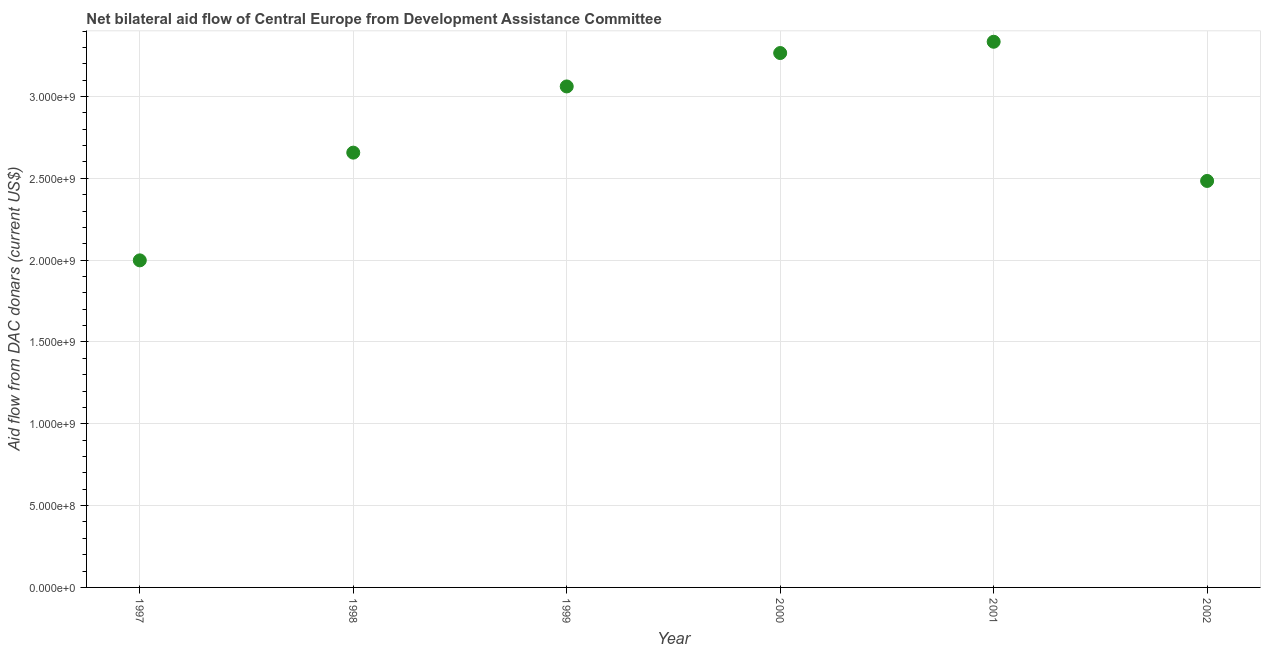What is the net bilateral aid flows from dac donors in 2001?
Offer a very short reply. 3.33e+09. Across all years, what is the maximum net bilateral aid flows from dac donors?
Make the answer very short. 3.33e+09. Across all years, what is the minimum net bilateral aid flows from dac donors?
Provide a short and direct response. 2.00e+09. In which year was the net bilateral aid flows from dac donors maximum?
Your answer should be compact. 2001. What is the sum of the net bilateral aid flows from dac donors?
Offer a terse response. 1.68e+1. What is the difference between the net bilateral aid flows from dac donors in 1997 and 2000?
Provide a succinct answer. -1.27e+09. What is the average net bilateral aid flows from dac donors per year?
Keep it short and to the point. 2.80e+09. What is the median net bilateral aid flows from dac donors?
Your answer should be very brief. 2.86e+09. What is the ratio of the net bilateral aid flows from dac donors in 1997 to that in 1998?
Offer a very short reply. 0.75. Is the net bilateral aid flows from dac donors in 1998 less than that in 2000?
Offer a terse response. Yes. Is the difference between the net bilateral aid flows from dac donors in 1997 and 2002 greater than the difference between any two years?
Give a very brief answer. No. What is the difference between the highest and the second highest net bilateral aid flows from dac donors?
Keep it short and to the point. 6.89e+07. Is the sum of the net bilateral aid flows from dac donors in 1998 and 2001 greater than the maximum net bilateral aid flows from dac donors across all years?
Provide a short and direct response. Yes. What is the difference between the highest and the lowest net bilateral aid flows from dac donors?
Your answer should be very brief. 1.34e+09. Does the net bilateral aid flows from dac donors monotonically increase over the years?
Provide a short and direct response. No. How many dotlines are there?
Keep it short and to the point. 1. Are the values on the major ticks of Y-axis written in scientific E-notation?
Your answer should be compact. Yes. What is the title of the graph?
Ensure brevity in your answer.  Net bilateral aid flow of Central Europe from Development Assistance Committee. What is the label or title of the X-axis?
Provide a short and direct response. Year. What is the label or title of the Y-axis?
Provide a short and direct response. Aid flow from DAC donars (current US$). What is the Aid flow from DAC donars (current US$) in 1997?
Give a very brief answer. 2.00e+09. What is the Aid flow from DAC donars (current US$) in 1998?
Make the answer very short. 2.66e+09. What is the Aid flow from DAC donars (current US$) in 1999?
Give a very brief answer. 3.06e+09. What is the Aid flow from DAC donars (current US$) in 2000?
Provide a short and direct response. 3.27e+09. What is the Aid flow from DAC donars (current US$) in 2001?
Offer a terse response. 3.33e+09. What is the Aid flow from DAC donars (current US$) in 2002?
Your answer should be very brief. 2.48e+09. What is the difference between the Aid flow from DAC donars (current US$) in 1997 and 1998?
Keep it short and to the point. -6.58e+08. What is the difference between the Aid flow from DAC donars (current US$) in 1997 and 1999?
Your answer should be compact. -1.06e+09. What is the difference between the Aid flow from DAC donars (current US$) in 1997 and 2000?
Provide a succinct answer. -1.27e+09. What is the difference between the Aid flow from DAC donars (current US$) in 1997 and 2001?
Your response must be concise. -1.34e+09. What is the difference between the Aid flow from DAC donars (current US$) in 1997 and 2002?
Make the answer very short. -4.85e+08. What is the difference between the Aid flow from DAC donars (current US$) in 1998 and 1999?
Your answer should be compact. -4.04e+08. What is the difference between the Aid flow from DAC donars (current US$) in 1998 and 2000?
Make the answer very short. -6.09e+08. What is the difference between the Aid flow from DAC donars (current US$) in 1998 and 2001?
Give a very brief answer. -6.78e+08. What is the difference between the Aid flow from DAC donars (current US$) in 1998 and 2002?
Provide a short and direct response. 1.73e+08. What is the difference between the Aid flow from DAC donars (current US$) in 1999 and 2000?
Give a very brief answer. -2.04e+08. What is the difference between the Aid flow from DAC donars (current US$) in 1999 and 2001?
Your response must be concise. -2.73e+08. What is the difference between the Aid flow from DAC donars (current US$) in 1999 and 2002?
Your answer should be very brief. 5.77e+08. What is the difference between the Aid flow from DAC donars (current US$) in 2000 and 2001?
Offer a very short reply. -6.89e+07. What is the difference between the Aid flow from DAC donars (current US$) in 2000 and 2002?
Provide a short and direct response. 7.82e+08. What is the difference between the Aid flow from DAC donars (current US$) in 2001 and 2002?
Provide a short and direct response. 8.51e+08. What is the ratio of the Aid flow from DAC donars (current US$) in 1997 to that in 1998?
Provide a succinct answer. 0.75. What is the ratio of the Aid flow from DAC donars (current US$) in 1997 to that in 1999?
Your answer should be compact. 0.65. What is the ratio of the Aid flow from DAC donars (current US$) in 1997 to that in 2000?
Your response must be concise. 0.61. What is the ratio of the Aid flow from DAC donars (current US$) in 1997 to that in 2001?
Make the answer very short. 0.6. What is the ratio of the Aid flow from DAC donars (current US$) in 1997 to that in 2002?
Your answer should be very brief. 0.81. What is the ratio of the Aid flow from DAC donars (current US$) in 1998 to that in 1999?
Offer a very short reply. 0.87. What is the ratio of the Aid flow from DAC donars (current US$) in 1998 to that in 2000?
Provide a short and direct response. 0.81. What is the ratio of the Aid flow from DAC donars (current US$) in 1998 to that in 2001?
Your answer should be very brief. 0.8. What is the ratio of the Aid flow from DAC donars (current US$) in 1998 to that in 2002?
Your answer should be very brief. 1.07. What is the ratio of the Aid flow from DAC donars (current US$) in 1999 to that in 2000?
Ensure brevity in your answer.  0.94. What is the ratio of the Aid flow from DAC donars (current US$) in 1999 to that in 2001?
Provide a succinct answer. 0.92. What is the ratio of the Aid flow from DAC donars (current US$) in 1999 to that in 2002?
Offer a terse response. 1.23. What is the ratio of the Aid flow from DAC donars (current US$) in 2000 to that in 2001?
Ensure brevity in your answer.  0.98. What is the ratio of the Aid flow from DAC donars (current US$) in 2000 to that in 2002?
Give a very brief answer. 1.31. What is the ratio of the Aid flow from DAC donars (current US$) in 2001 to that in 2002?
Provide a succinct answer. 1.34. 